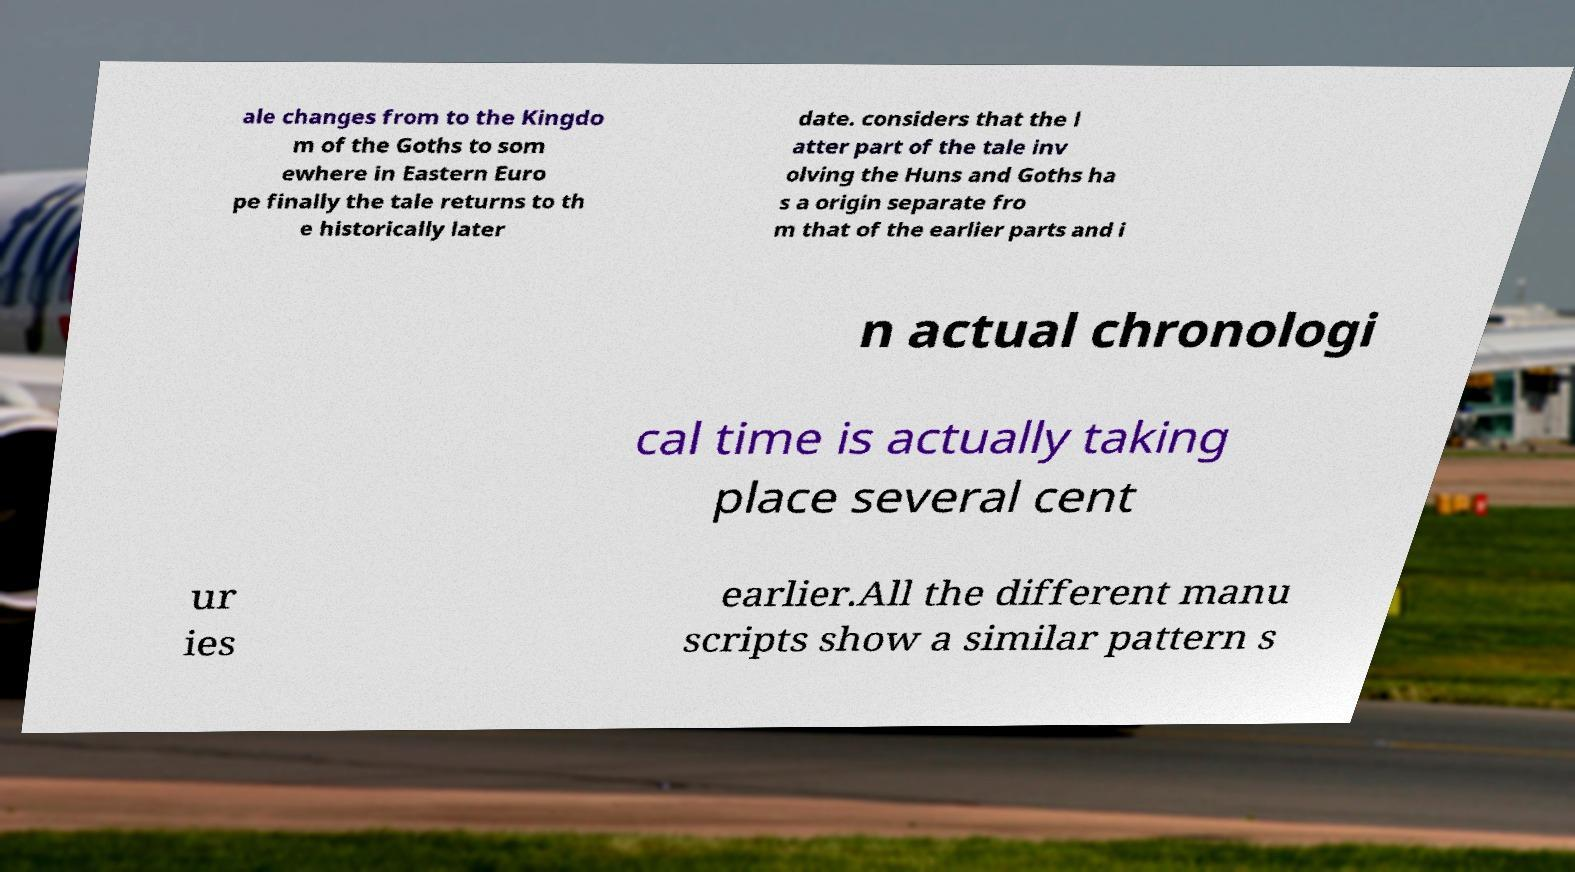Can you accurately transcribe the text from the provided image for me? ale changes from to the Kingdo m of the Goths to som ewhere in Eastern Euro pe finally the tale returns to th e historically later date. considers that the l atter part of the tale inv olving the Huns and Goths ha s a origin separate fro m that of the earlier parts and i n actual chronologi cal time is actually taking place several cent ur ies earlier.All the different manu scripts show a similar pattern s 